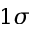<formula> <loc_0><loc_0><loc_500><loc_500>1 \sigma</formula> 